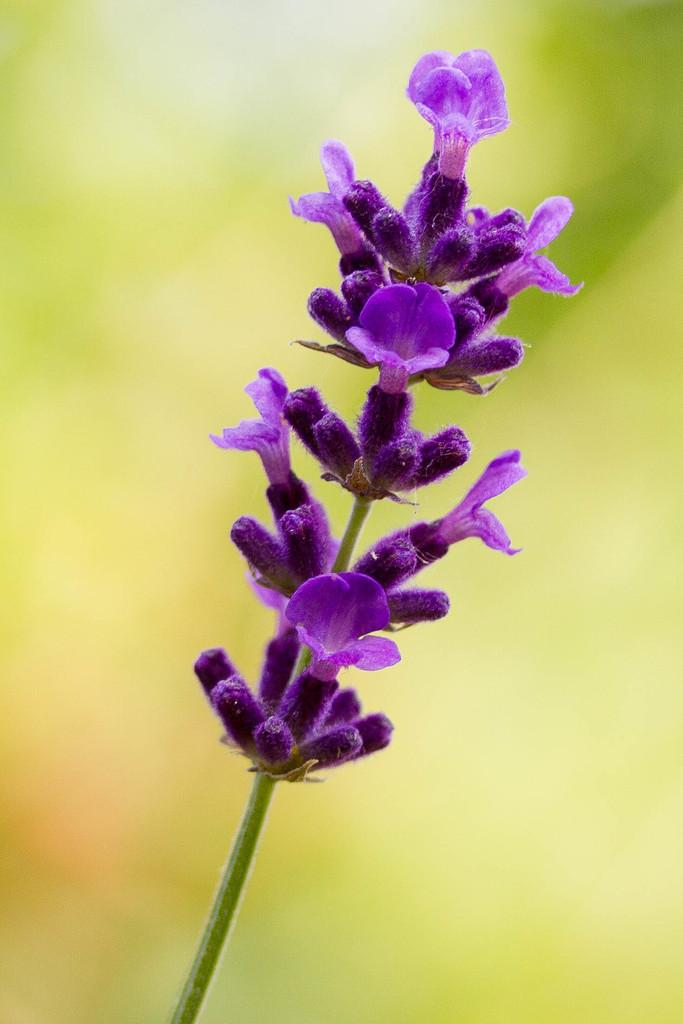What type of plant life is present in the image? There are flowers in the image. What color are the flowers and buds in the image? The flowers and buds are in purple color. Can you describe the structure of the flowers and buds in the image? There is a stem at the bottom of the flowers and buds. How many kittens are playing with the flock of birds in the image? There are no kittens or birds present in the image; it features flowers and buds with a stem. 